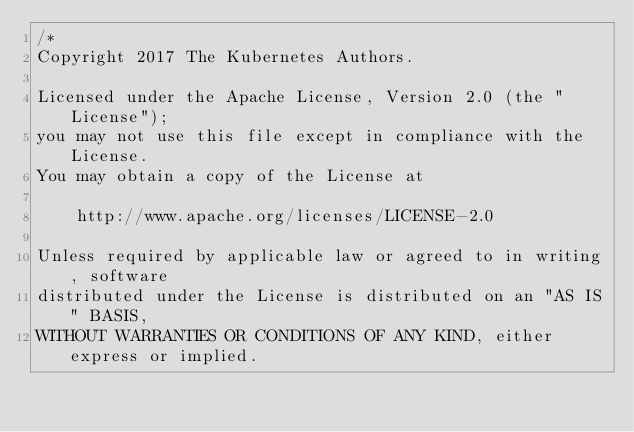<code> <loc_0><loc_0><loc_500><loc_500><_Go_>/*
Copyright 2017 The Kubernetes Authors.

Licensed under the Apache License, Version 2.0 (the "License");
you may not use this file except in compliance with the License.
You may obtain a copy of the License at

    http://www.apache.org/licenses/LICENSE-2.0

Unless required by applicable law or agreed to in writing, software
distributed under the License is distributed on an "AS IS" BASIS,
WITHOUT WARRANTIES OR CONDITIONS OF ANY KIND, either express or implied.</code> 